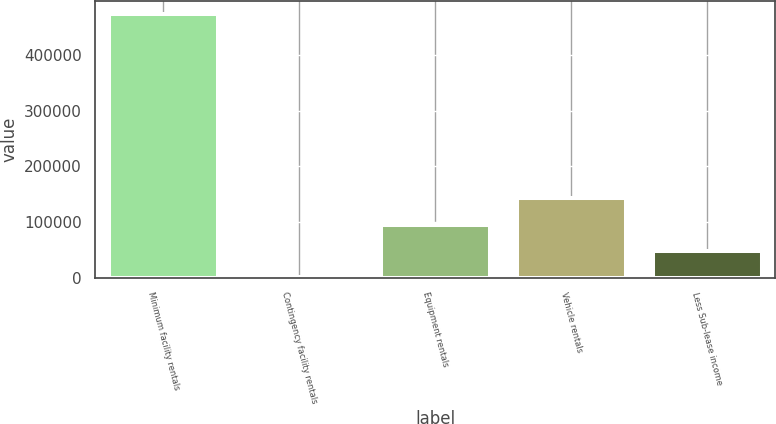Convert chart. <chart><loc_0><loc_0><loc_500><loc_500><bar_chart><fcel>Minimum facility rentals<fcel>Contingency facility rentals<fcel>Equipment rentals<fcel>Vehicle rentals<fcel>Less Sub-lease income<nl><fcel>473156<fcel>440<fcel>94983.2<fcel>142255<fcel>47711.6<nl></chart> 